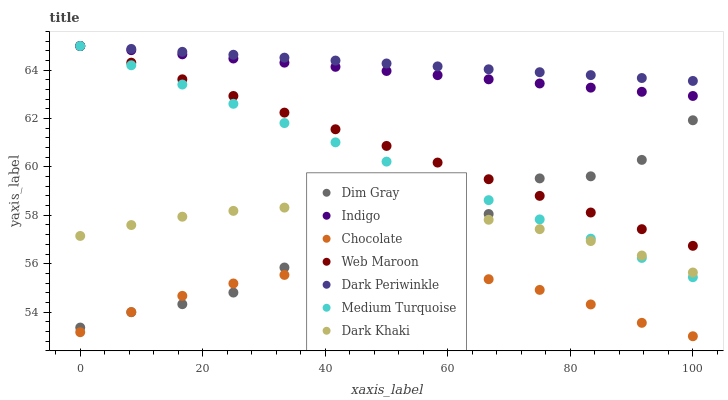Does Chocolate have the minimum area under the curve?
Answer yes or no. Yes. Does Dark Periwinkle have the maximum area under the curve?
Answer yes or no. Yes. Does Indigo have the minimum area under the curve?
Answer yes or no. No. Does Indigo have the maximum area under the curve?
Answer yes or no. No. Is Dark Periwinkle the smoothest?
Answer yes or no. Yes. Is Dim Gray the roughest?
Answer yes or no. Yes. Is Indigo the smoothest?
Answer yes or no. No. Is Indigo the roughest?
Answer yes or no. No. Does Chocolate have the lowest value?
Answer yes or no. Yes. Does Indigo have the lowest value?
Answer yes or no. No. Does Dark Periwinkle have the highest value?
Answer yes or no. Yes. Does Chocolate have the highest value?
Answer yes or no. No. Is Dark Khaki less than Dark Periwinkle?
Answer yes or no. Yes. Is Dark Periwinkle greater than Chocolate?
Answer yes or no. Yes. Does Medium Turquoise intersect Dark Periwinkle?
Answer yes or no. Yes. Is Medium Turquoise less than Dark Periwinkle?
Answer yes or no. No. Is Medium Turquoise greater than Dark Periwinkle?
Answer yes or no. No. Does Dark Khaki intersect Dark Periwinkle?
Answer yes or no. No. 